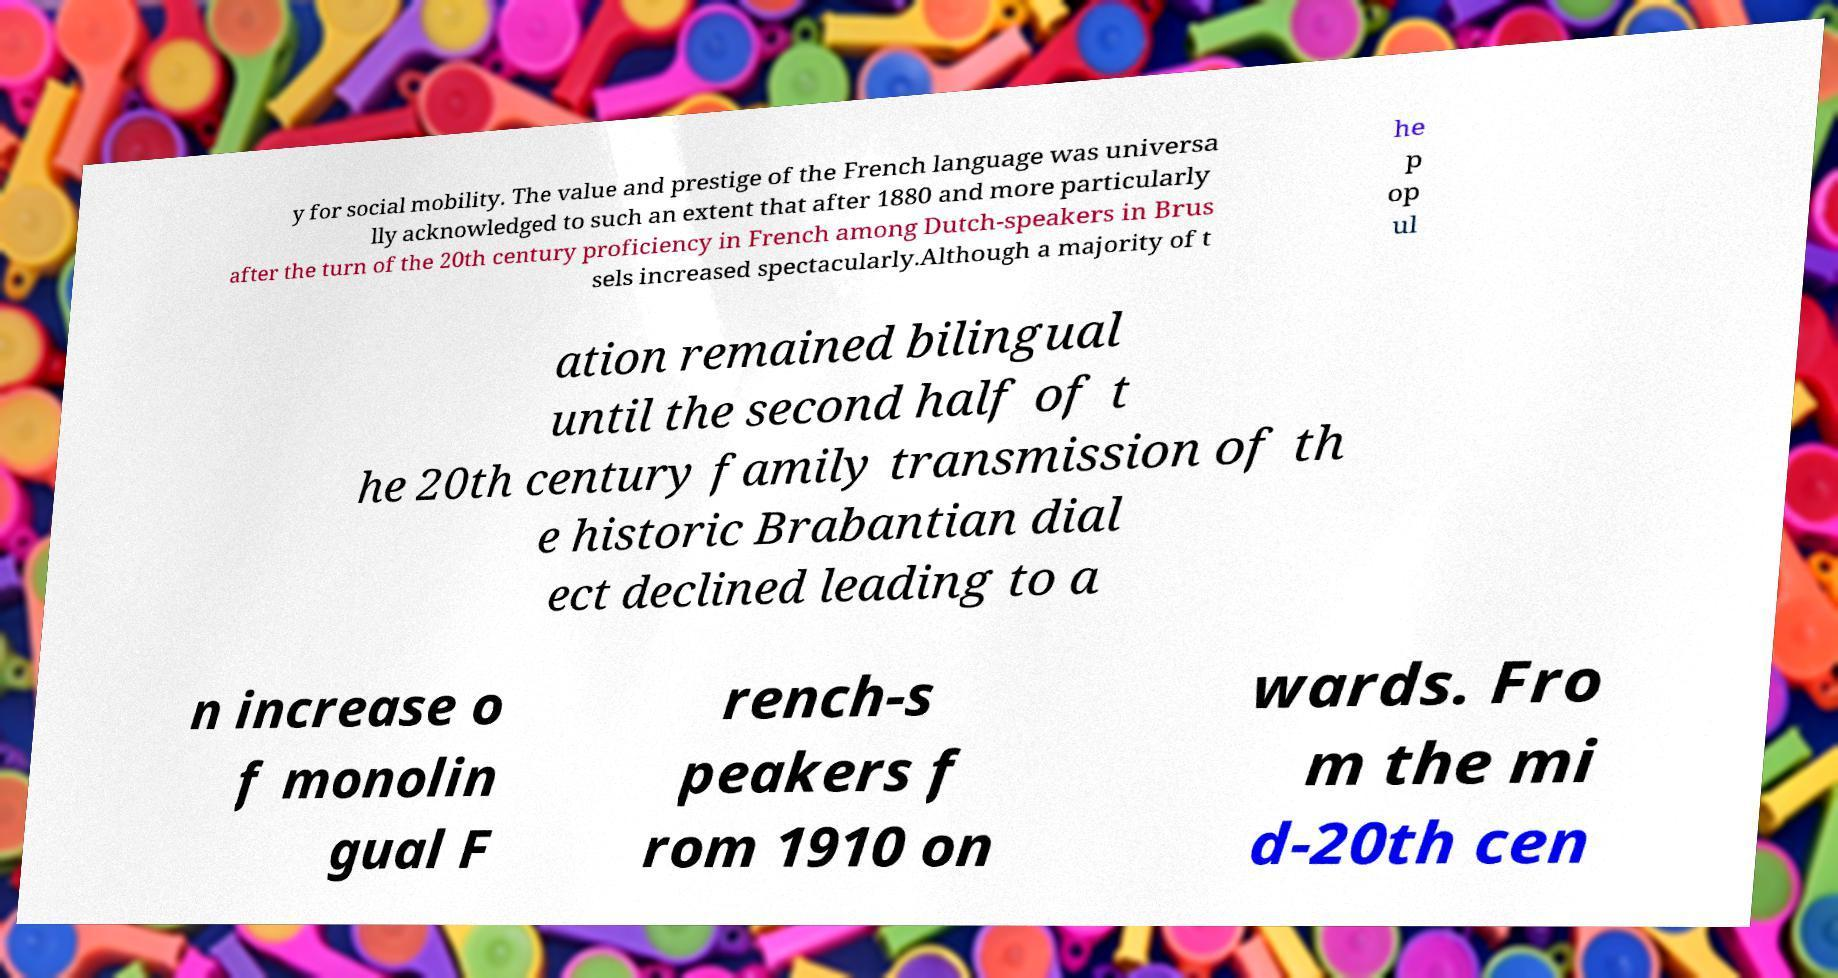There's text embedded in this image that I need extracted. Can you transcribe it verbatim? y for social mobility. The value and prestige of the French language was universa lly acknowledged to such an extent that after 1880 and more particularly after the turn of the 20th century proficiency in French among Dutch-speakers in Brus sels increased spectacularly.Although a majority of t he p op ul ation remained bilingual until the second half of t he 20th century family transmission of th e historic Brabantian dial ect declined leading to a n increase o f monolin gual F rench-s peakers f rom 1910 on wards. Fro m the mi d-20th cen 